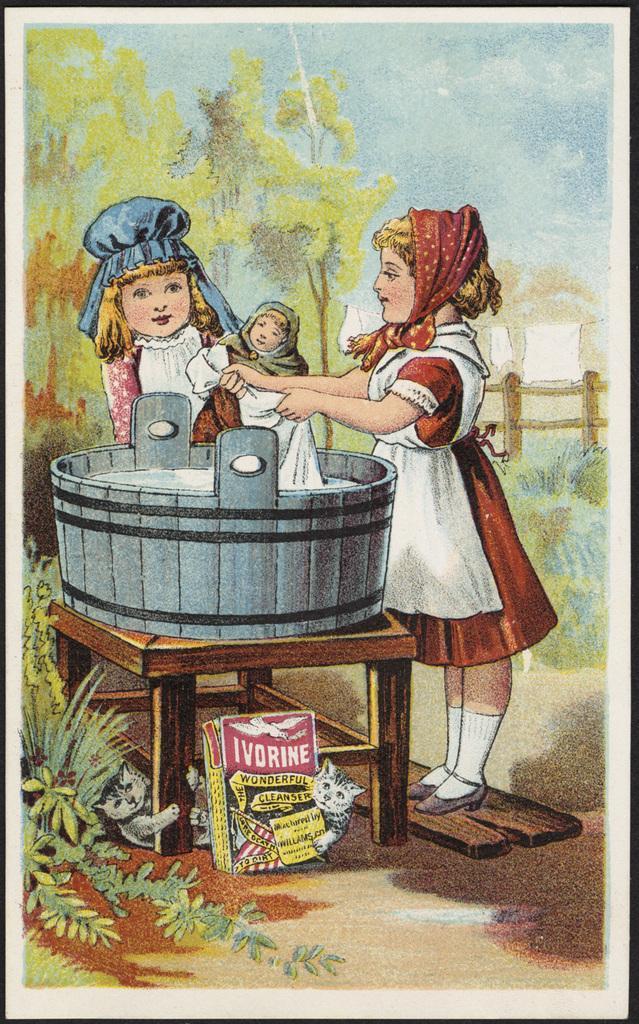Can you describe this image briefly? In this image this is a painting picture as we can see there is one kid on the right side of this image and one more kid at left side of this image,This kid holding a baby. There is a table in the bottom of this image and there are some objects kept on it. There are some trees in the background. There is a fencing wall on the right side of this image. There is a sky on the top of this image. 